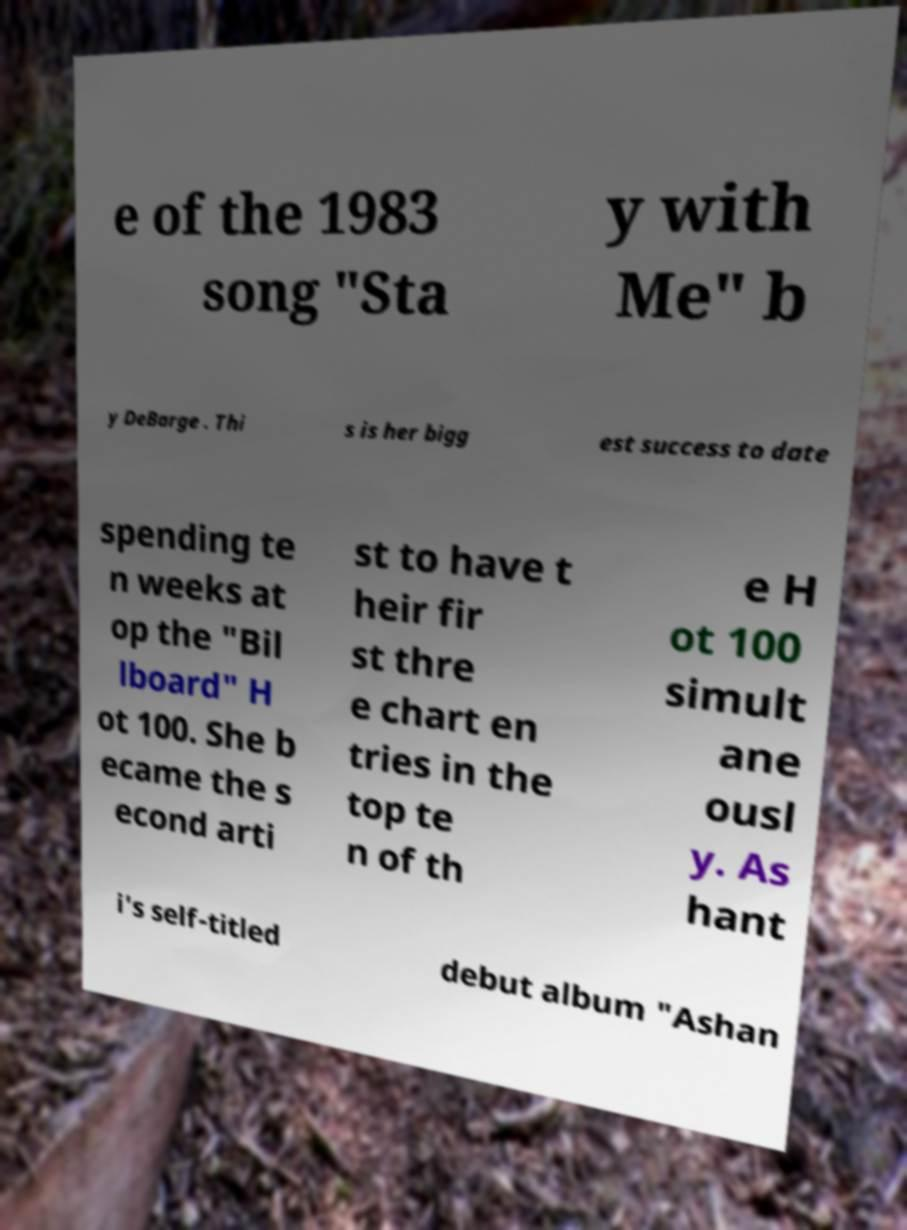There's text embedded in this image that I need extracted. Can you transcribe it verbatim? e of the 1983 song "Sta y with Me" b y DeBarge . Thi s is her bigg est success to date spending te n weeks at op the "Bil lboard" H ot 100. She b ecame the s econd arti st to have t heir fir st thre e chart en tries in the top te n of th e H ot 100 simult ane ousl y. As hant i's self-titled debut album "Ashan 